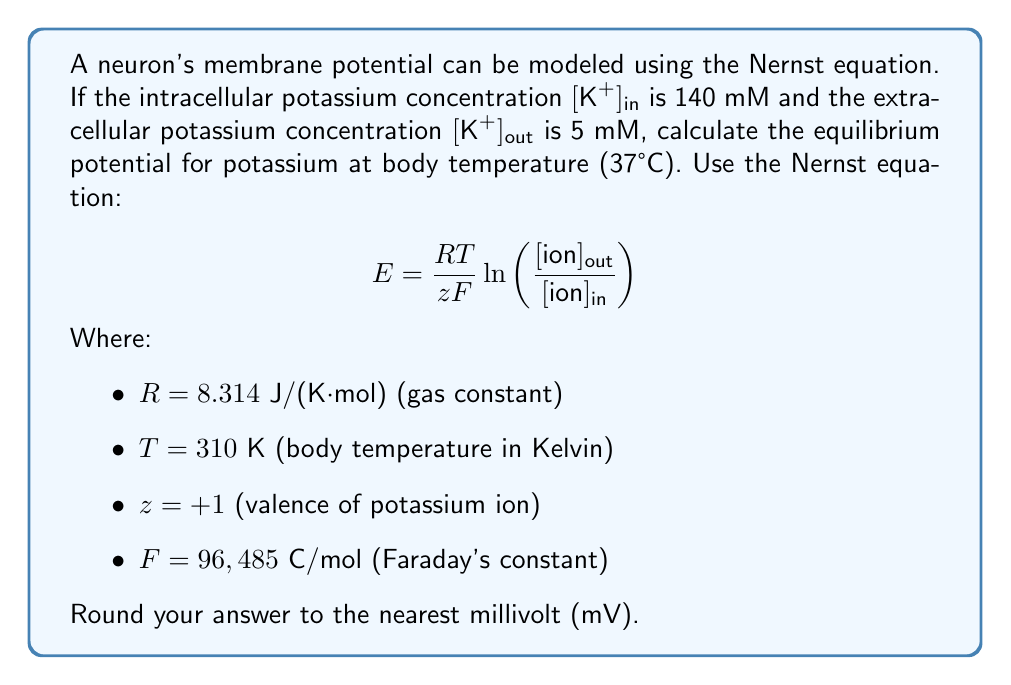Could you help me with this problem? To solve this problem, we'll use the Nernst equation and plug in the given values:

1) First, let's organize our values:
   $R = 8.314 \text{ J/(K·mol)}$
   $T = 310 \text{ K}$
   $z = +1$
   $F = 96,485 \text{ C/mol}$
   $[K^+]_{out} = 5 \text{ mM}$
   $[K^+]_{in} = 140 \text{ mM}$

2) Now, let's substitute these values into the Nernst equation:

   $$ E = \frac{8.314 \text{ J/(K·mol)} \times 310 \text{ K}}{(+1) \times 96,485 \text{ C/mol}} \ln\left(\frac{5 \text{ mM}}{140 \text{ mM}}\right) $$

3) Simplify the fraction in front of the natural logarithm:

   $$ E = 0.02656 \text{ V} \times \ln\left(\frac{5}{140}\right) $$

4) Calculate the natural logarithm:

   $$ E = 0.02656 \text{ V} \times (-3.3322) $$

5) Multiply:

   $$ E = -0.08850 \text{ V} $$

6) Convert to millivolts:

   $$ E = -88.50 \text{ mV} $$

7) Rounding to the nearest millivolt:

   $$ E = -89 \text{ mV} $$
Answer: The equilibrium potential for potassium at body temperature is -89 mV. 